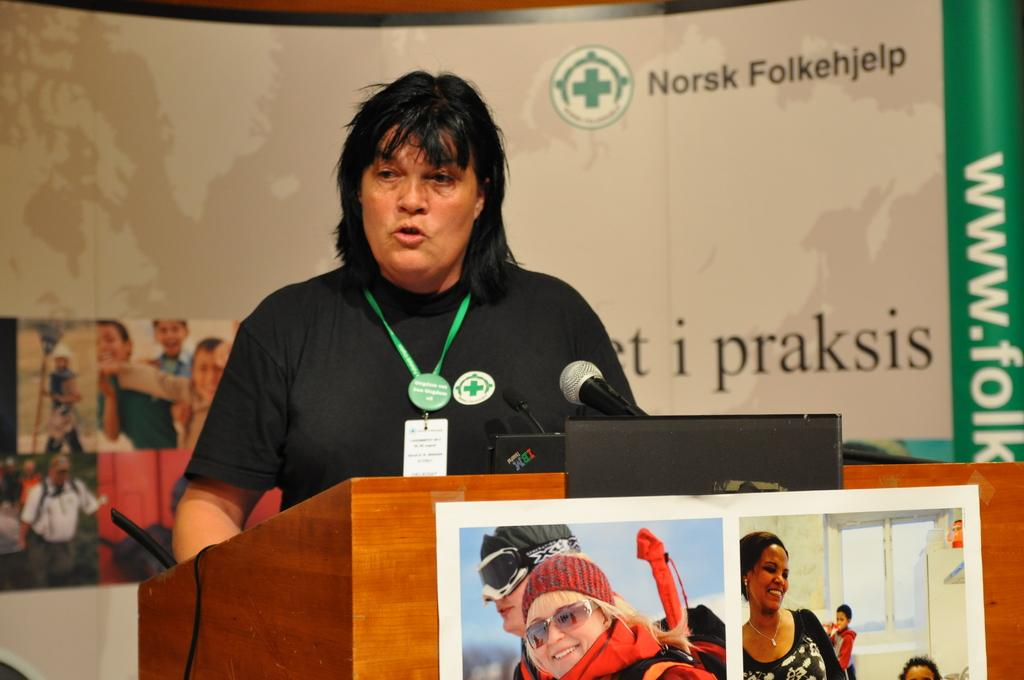What is the man in the image doing? The man is standing at a podium in the image. What object is the man using to communicate in the image? There is a microphone in the image that the man might be using. What can be seen on the podium in the image? There are posters on the podium in the image. What additional feature is visible in the image? There is an advertisement board visible in the image. What type of mailbox can be seen in the image? There is no mailbox present in the image. How does the audience react to the man's speech in the image? The image does not show the audience's reaction to the man's speech, so it cannot be determined from the image. 